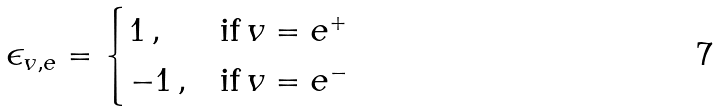<formula> <loc_0><loc_0><loc_500><loc_500>\epsilon _ { v , e } = \begin{cases} 1 \, , & \text {if} \, v = e ^ { + } \\ - 1 \, , & \text {if} \, v = e ^ { - } \, \end{cases}</formula> 